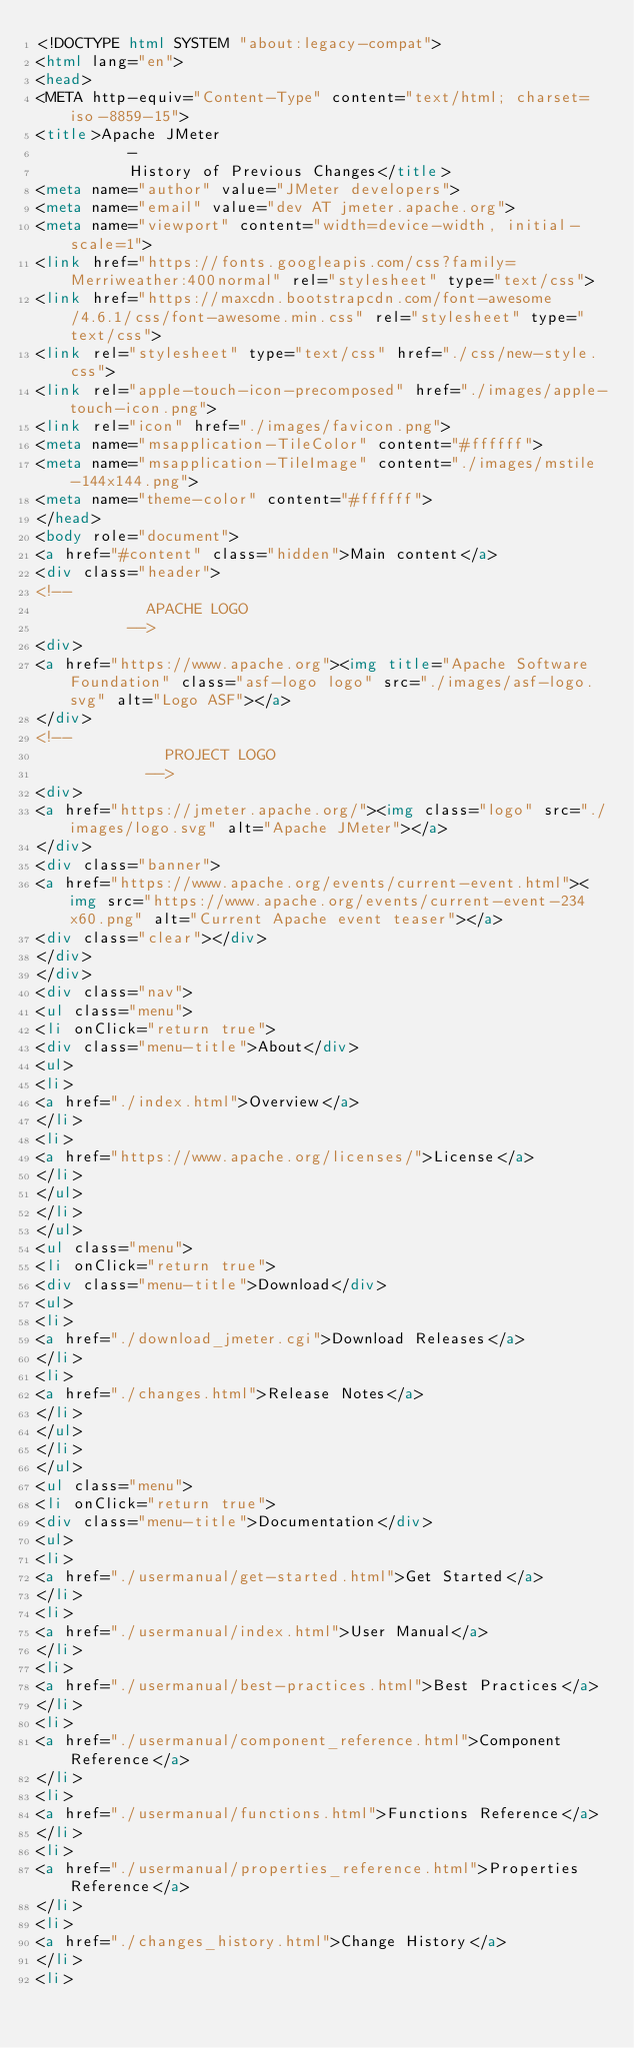<code> <loc_0><loc_0><loc_500><loc_500><_HTML_><!DOCTYPE html SYSTEM "about:legacy-compat">
<html lang="en">
<head>
<META http-equiv="Content-Type" content="text/html; charset=iso-8859-15">
<title>Apache JMeter
          -
          History of Previous Changes</title>
<meta name="author" value="JMeter developers">
<meta name="email" value="dev AT jmeter.apache.org">
<meta name="viewport" content="width=device-width, initial-scale=1">
<link href="https://fonts.googleapis.com/css?family=Merriweather:400normal" rel="stylesheet" type="text/css">
<link href="https://maxcdn.bootstrapcdn.com/font-awesome/4.6.1/css/font-awesome.min.css" rel="stylesheet" type="text/css">
<link rel="stylesheet" type="text/css" href="./css/new-style.css">
<link rel="apple-touch-icon-precomposed" href="./images/apple-touch-icon.png">
<link rel="icon" href="./images/favicon.png">
<meta name="msapplication-TileColor" content="#ffffff">
<meta name="msapplication-TileImage" content="./images/mstile-144x144.png">
<meta name="theme-color" content="#ffffff">
</head>
<body role="document">
<a href="#content" class="hidden">Main content</a>
<div class="header">
<!--
            APACHE LOGO
          -->
<div>
<a href="https://www.apache.org"><img title="Apache Software Foundation" class="asf-logo logo" src="./images/asf-logo.svg" alt="Logo ASF"></a>
</div>
<!--
              PROJECT LOGO
            -->
<div>
<a href="https://jmeter.apache.org/"><img class="logo" src="./images/logo.svg" alt="Apache JMeter"></a>
</div>
<div class="banner">
<a href="https://www.apache.org/events/current-event.html"><img src="https://www.apache.org/events/current-event-234x60.png" alt="Current Apache event teaser"></a>
<div class="clear"></div>
</div>
</div>
<div class="nav">
<ul class="menu">
<li onClick="return true">
<div class="menu-title">About</div>
<ul>
<li>
<a href="./index.html">Overview</a>
</li>
<li>
<a href="https://www.apache.org/licenses/">License</a>
</li>
</ul>
</li>
</ul>
<ul class="menu">
<li onClick="return true">
<div class="menu-title">Download</div>
<ul>
<li>
<a href="./download_jmeter.cgi">Download Releases</a>
</li>
<li>
<a href="./changes.html">Release Notes</a>
</li>
</ul>
</li>
</ul>
<ul class="menu">
<li onClick="return true">
<div class="menu-title">Documentation</div>
<ul>
<li>
<a href="./usermanual/get-started.html">Get Started</a>
</li>
<li>
<a href="./usermanual/index.html">User Manual</a>
</li>
<li>
<a href="./usermanual/best-practices.html">Best Practices</a>
</li>
<li>
<a href="./usermanual/component_reference.html">Component Reference</a>
</li>
<li>
<a href="./usermanual/functions.html">Functions Reference</a>
</li>
<li>
<a href="./usermanual/properties_reference.html">Properties Reference</a>
</li>
<li>
<a href="./changes_history.html">Change History</a>
</li>
<li></code> 